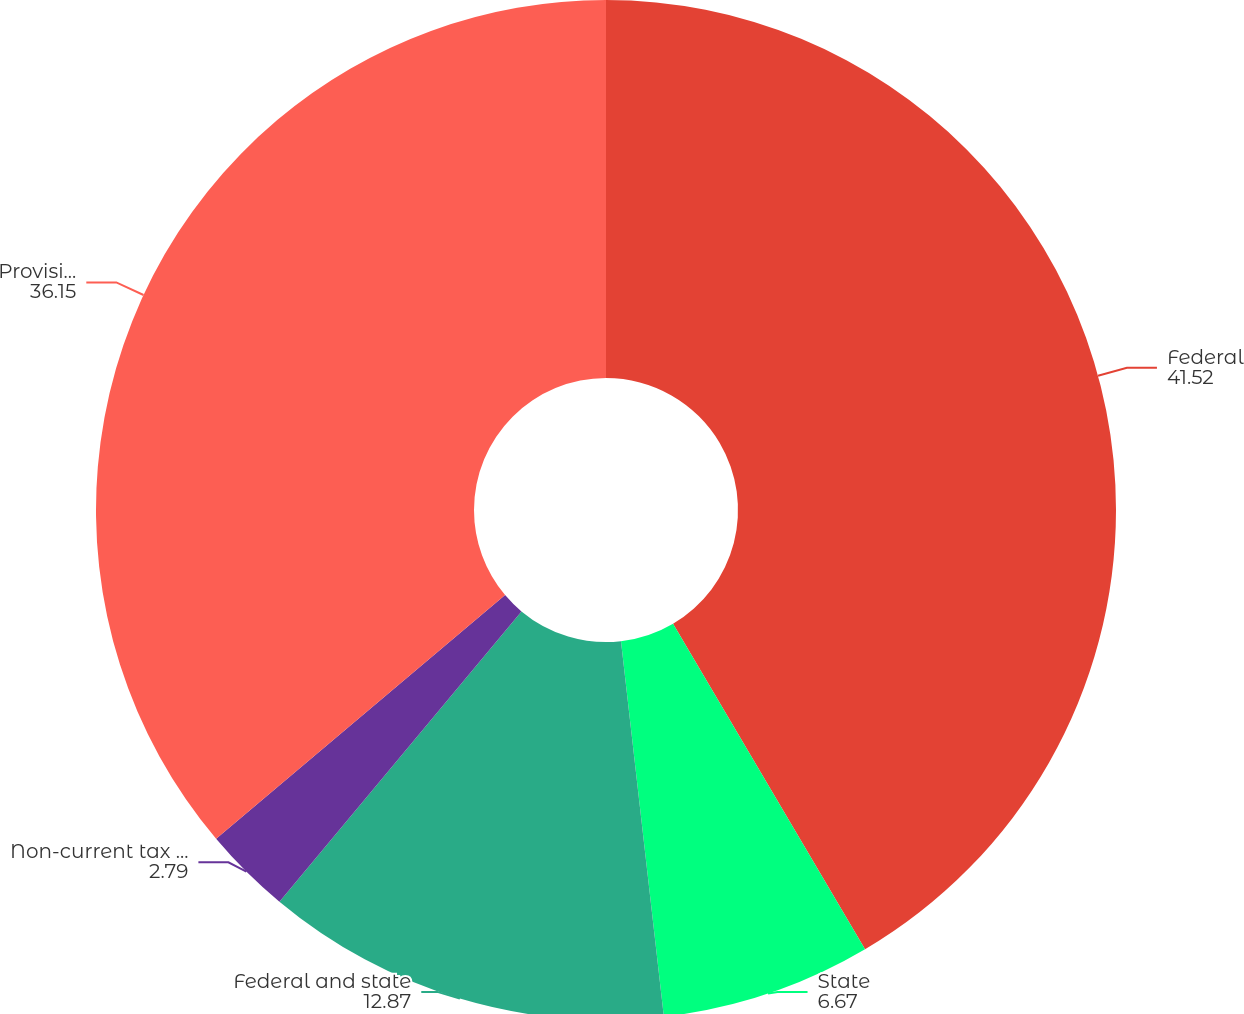Convert chart to OTSL. <chart><loc_0><loc_0><loc_500><loc_500><pie_chart><fcel>Federal<fcel>State<fcel>Federal and state<fcel>Non-current tax provision<fcel>Provision for income taxes<nl><fcel>41.52%<fcel>6.67%<fcel>12.87%<fcel>2.79%<fcel>36.15%<nl></chart> 